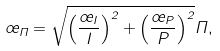<formula> <loc_0><loc_0><loc_500><loc_500>\sigma _ { \Pi } = \sqrt { \left ( \frac { \sigma _ { I } } { I } \right ) ^ { 2 } + \left ( \frac { \sigma _ { P } } { P } \right ) ^ { 2 } } \Pi ,</formula> 